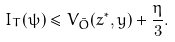Convert formula to latex. <formula><loc_0><loc_0><loc_500><loc_500>I _ { T } ( \psi ) \leq V _ { \bar { O } } ( z ^ { \ast } , y ) + \frac { \eta } { 3 } .</formula> 